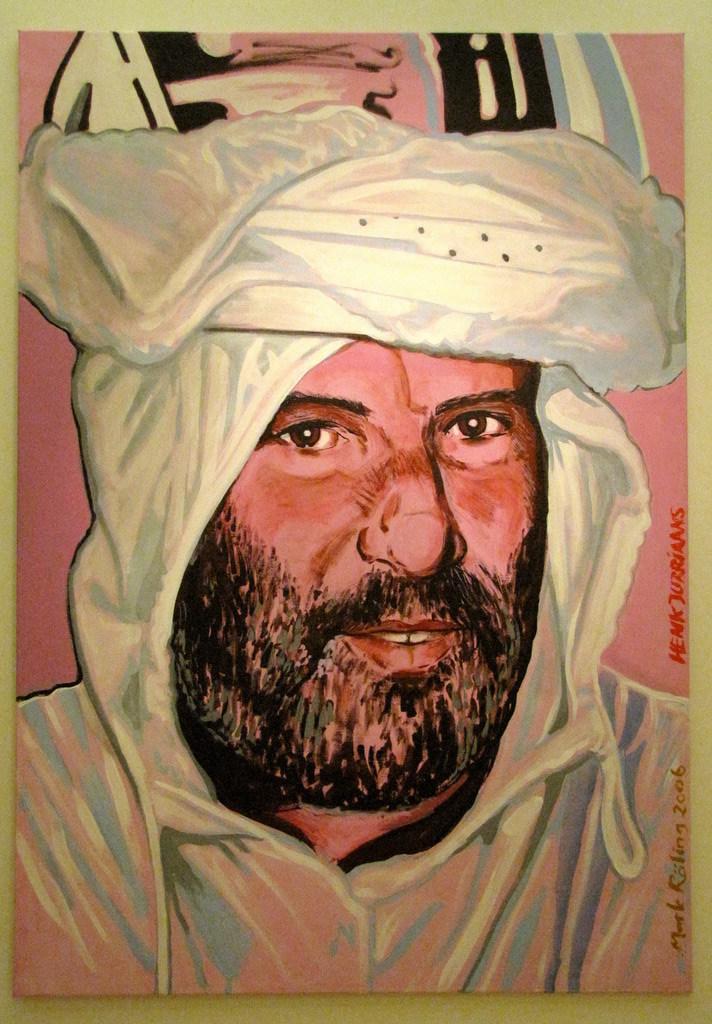In one or two sentences, can you explain what this image depicts? In the foreground of this image, there is a frame, on which there is a painting of a man which is on the white surface. 